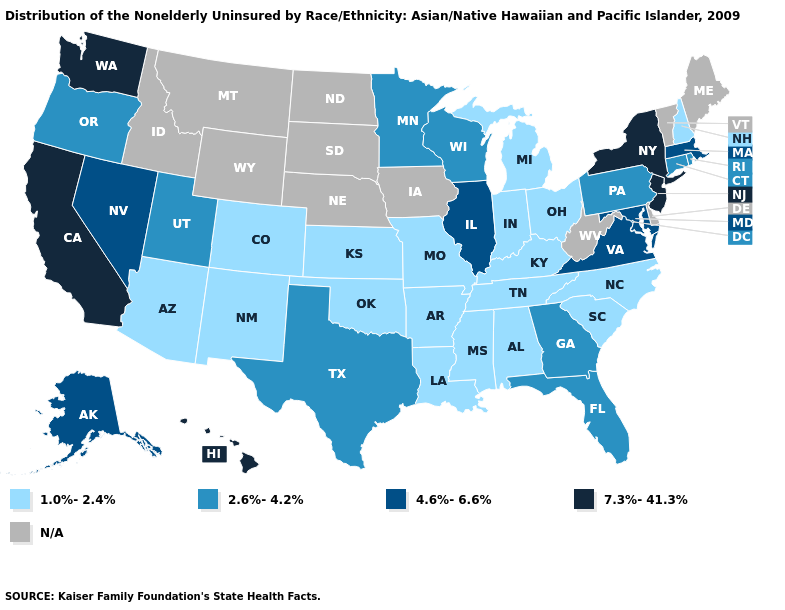Name the states that have a value in the range N/A?
Concise answer only. Delaware, Idaho, Iowa, Maine, Montana, Nebraska, North Dakota, South Dakota, Vermont, West Virginia, Wyoming. Among the states that border South Carolina , does North Carolina have the highest value?
Concise answer only. No. Does Washington have the highest value in the West?
Keep it brief. Yes. Which states have the lowest value in the South?
Give a very brief answer. Alabama, Arkansas, Kentucky, Louisiana, Mississippi, North Carolina, Oklahoma, South Carolina, Tennessee. What is the value of California?
Concise answer only. 7.3%-41.3%. What is the lowest value in the USA?
Concise answer only. 1.0%-2.4%. Name the states that have a value in the range 2.6%-4.2%?
Keep it brief. Connecticut, Florida, Georgia, Minnesota, Oregon, Pennsylvania, Rhode Island, Texas, Utah, Wisconsin. What is the value of Iowa?
Give a very brief answer. N/A. Which states have the lowest value in the Northeast?
Short answer required. New Hampshire. Name the states that have a value in the range 2.6%-4.2%?
Concise answer only. Connecticut, Florida, Georgia, Minnesota, Oregon, Pennsylvania, Rhode Island, Texas, Utah, Wisconsin. Among the states that border West Virginia , which have the lowest value?
Keep it brief. Kentucky, Ohio. Name the states that have a value in the range 2.6%-4.2%?
Give a very brief answer. Connecticut, Florida, Georgia, Minnesota, Oregon, Pennsylvania, Rhode Island, Texas, Utah, Wisconsin. Which states have the lowest value in the Northeast?
Keep it brief. New Hampshire. 